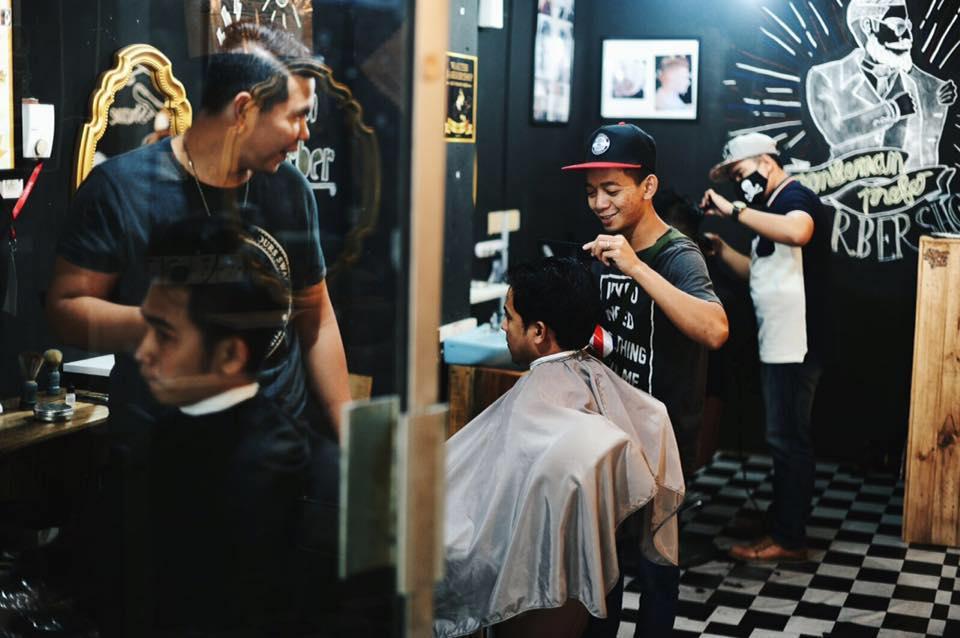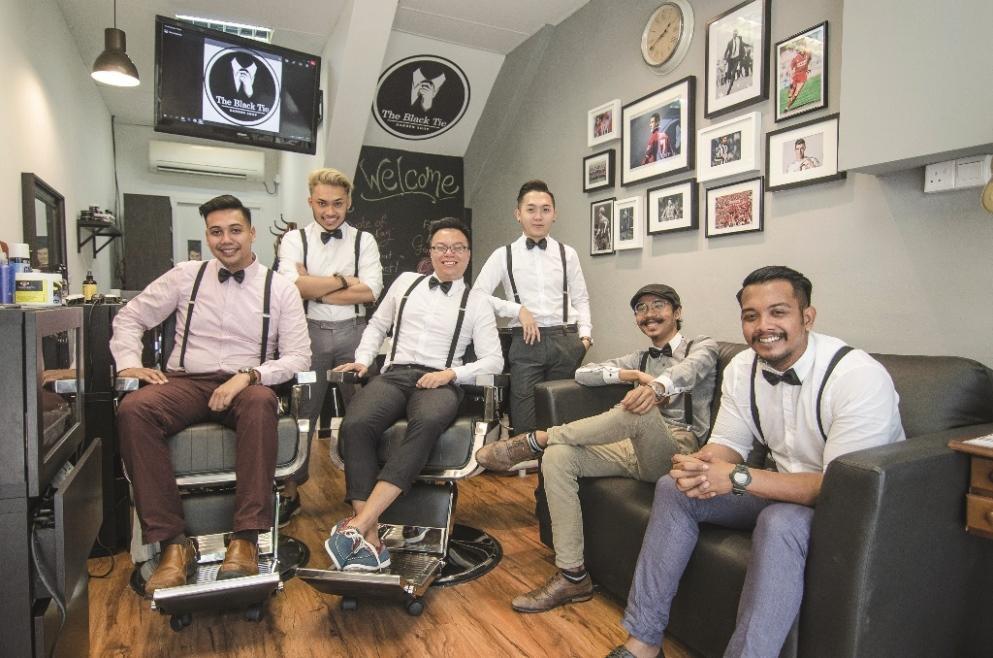The first image is the image on the left, the second image is the image on the right. For the images shown, is this caption "There are more than four people." true? Answer yes or no. Yes. The first image is the image on the left, the second image is the image on the right. Given the left and right images, does the statement "There are no more than four people in the barber shop." hold true? Answer yes or no. No. 